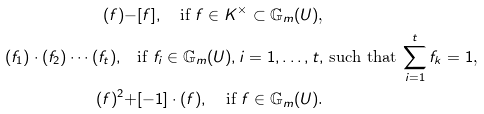Convert formula to latex. <formula><loc_0><loc_0><loc_500><loc_500>( f ) - & [ f ] , \quad \text {if $f\in K^{\times}\subset \mathbb{G}_{m}(U)$,} \\ ( f _ { 1 } ) \cdot ( f _ { 2 } ) \cdots ( f _ { t } ) , \quad & \text {if $f_{i}\in \mathbb{G}_{m}(U),  i=1,\dots,t,$ such that $\sum_{i=1}^{t}{f_{k}}=1$,} \\ ( f ) ^ { 2 } + & [ - 1 ] \cdot ( f ) , \quad \text {if $f\in \mathbb{G}_{m}(U)$.}</formula> 